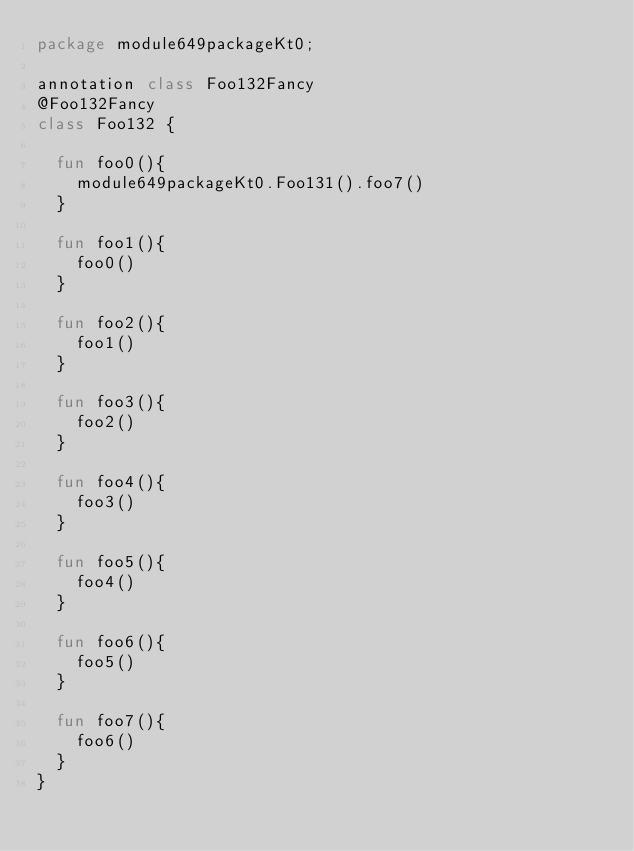Convert code to text. <code><loc_0><loc_0><loc_500><loc_500><_Kotlin_>package module649packageKt0;

annotation class Foo132Fancy
@Foo132Fancy
class Foo132 {

  fun foo0(){
    module649packageKt0.Foo131().foo7()
  }

  fun foo1(){
    foo0()
  }

  fun foo2(){
    foo1()
  }

  fun foo3(){
    foo2()
  }

  fun foo4(){
    foo3()
  }

  fun foo5(){
    foo4()
  }

  fun foo6(){
    foo5()
  }

  fun foo7(){
    foo6()
  }
}</code> 